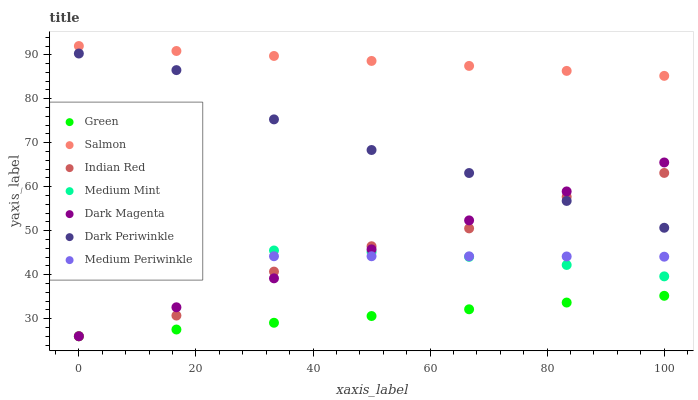Does Green have the minimum area under the curve?
Answer yes or no. Yes. Does Salmon have the maximum area under the curve?
Answer yes or no. Yes. Does Dark Magenta have the minimum area under the curve?
Answer yes or no. No. Does Dark Magenta have the maximum area under the curve?
Answer yes or no. No. Is Green the smoothest?
Answer yes or no. Yes. Is Indian Red the roughest?
Answer yes or no. Yes. Is Dark Magenta the smoothest?
Answer yes or no. No. Is Dark Magenta the roughest?
Answer yes or no. No. Does Dark Magenta have the lowest value?
Answer yes or no. Yes. Does Medium Periwinkle have the lowest value?
Answer yes or no. No. Does Salmon have the highest value?
Answer yes or no. Yes. Does Dark Magenta have the highest value?
Answer yes or no. No. Is Green less than Medium Mint?
Answer yes or no. Yes. Is Dark Periwinkle greater than Medium Periwinkle?
Answer yes or no. Yes. Does Indian Red intersect Medium Periwinkle?
Answer yes or no. Yes. Is Indian Red less than Medium Periwinkle?
Answer yes or no. No. Is Indian Red greater than Medium Periwinkle?
Answer yes or no. No. Does Green intersect Medium Mint?
Answer yes or no. No. 